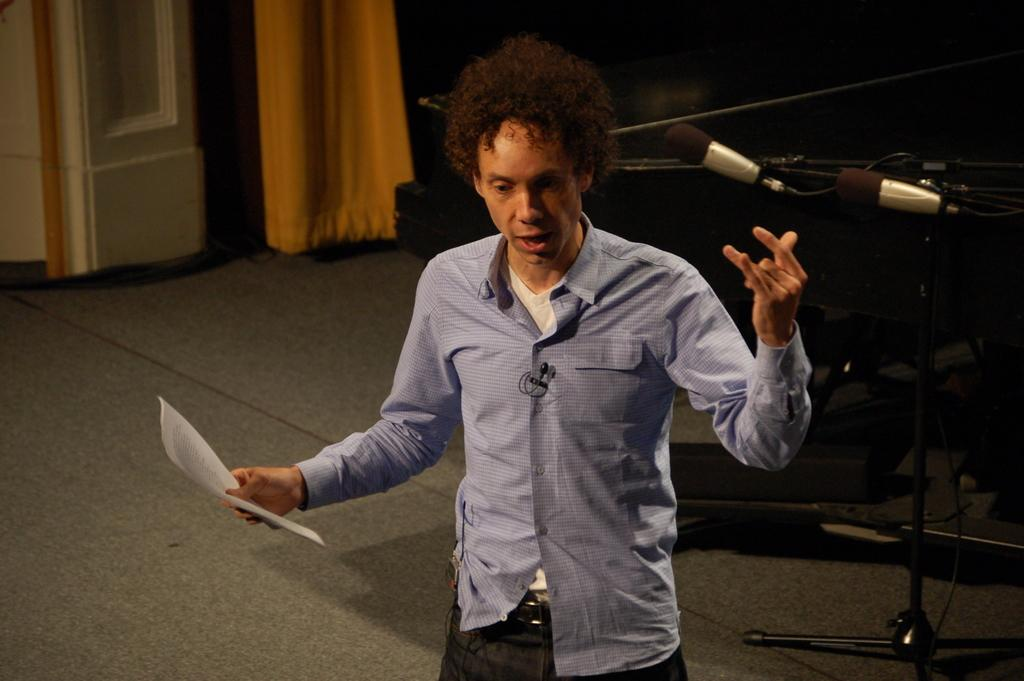What is the person in the image doing? The person is holding a paper. What object is beside the person? There is a microphone beside the person. What can be seen in the background of the image? There is a curtain and a white color object that looks like a pillar in the background. What did the person's mom say about the summer in the image? There is no mention of a mom or summer in the image, so it is not possible to answer that question. 